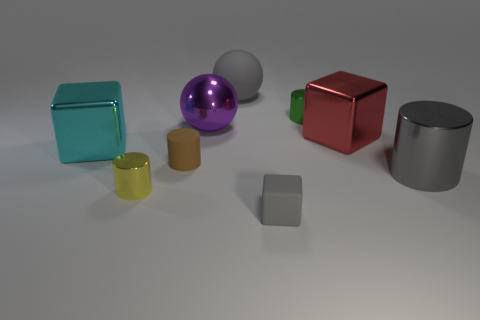There is a green thing that is the same size as the rubber cylinder; what is it made of?
Provide a succinct answer. Metal. The gray matte object that is the same size as the purple metallic sphere is what shape?
Your response must be concise. Sphere. How many other things are the same color as the big cylinder?
Give a very brief answer. 2. What is the material of the tiny yellow cylinder?
Provide a short and direct response. Metal. What number of other objects are the same material as the small block?
Keep it short and to the point. 2. There is a cylinder that is both right of the purple ball and in front of the purple ball; what is its size?
Ensure brevity in your answer.  Large. What is the shape of the rubber object to the right of the rubber thing that is behind the cyan shiny object?
Provide a short and direct response. Cube. Are there the same number of metallic things behind the tiny brown rubber object and small things?
Offer a terse response. Yes. Does the big cylinder have the same color as the matte object on the right side of the big gray matte ball?
Ensure brevity in your answer.  Yes. There is a metallic thing that is both left of the tiny green metallic cylinder and behind the cyan thing; what is its color?
Offer a terse response. Purple. 